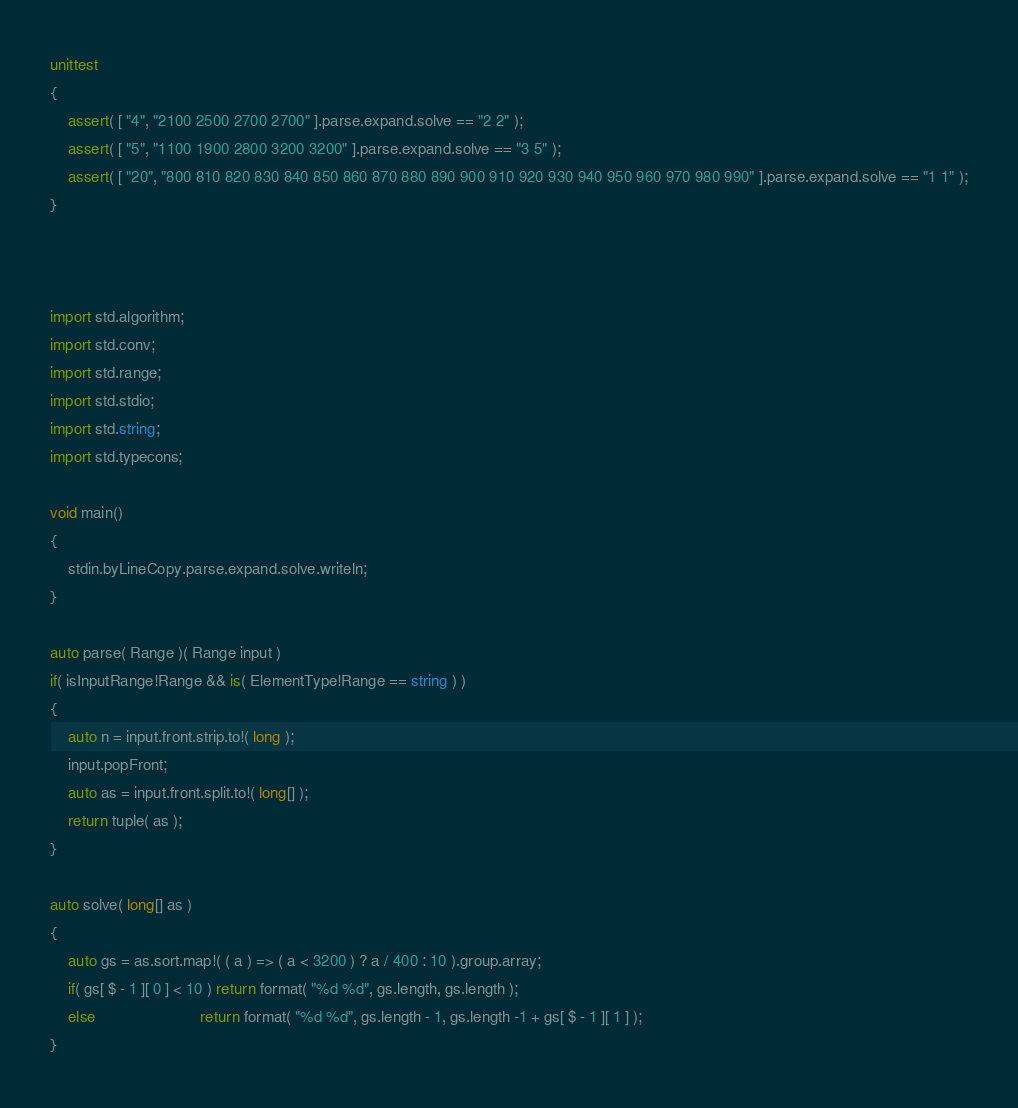Convert code to text. <code><loc_0><loc_0><loc_500><loc_500><_D_>unittest
{
	assert( [ "4", "2100 2500 2700 2700" ].parse.expand.solve == "2 2" );
	assert( [ "5", "1100 1900 2800 3200 3200" ].parse.expand.solve == "3 5" );
	assert( [ "20", "800 810 820 830 840 850 860 870 880 890 900 910 920 930 940 950 960 970 980 990" ].parse.expand.solve == "1 1" );
}



import std.algorithm;
import std.conv;
import std.range;
import std.stdio;
import std.string;
import std.typecons;

void main()
{
	stdin.byLineCopy.parse.expand.solve.writeln;
}

auto parse( Range )( Range input )
if( isInputRange!Range && is( ElementType!Range == string ) )
{
	auto n = input.front.strip.to!( long );
	input.popFront;
	auto as = input.front.split.to!( long[] );
	return tuple( as );
}

auto solve( long[] as )
{
	auto gs = as.sort.map!( ( a ) => ( a < 3200 ) ? a / 400 : 10 ).group.array;
	if( gs[ $ - 1 ][ 0 ] < 10 ) return format( "%d %d", gs.length, gs.length );
	else                        return format( "%d %d", gs.length - 1, gs.length -1 + gs[ $ - 1 ][ 1 ] );
}
</code> 